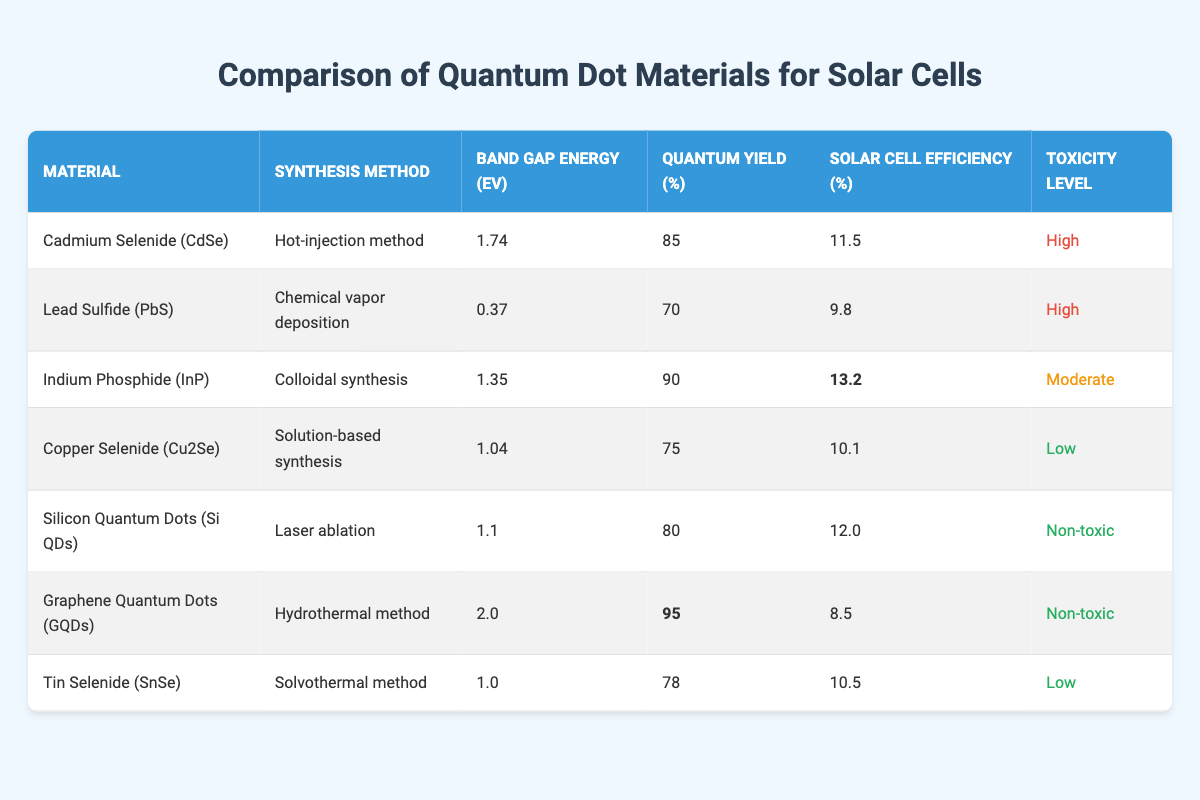What material has the highest solar cell efficiency? The solar cell efficiency of each material is listed in the table. By scanning through the values, Indium Phosphide (InP) has the highest solar cell efficiency at 13.2%.
Answer: Indium Phosphide (InP) Which material has the lowest band gap energy? The band gap energy for each material is provided. Among them, Lead Sulfide (PbS) has the lowest band gap energy of 0.37 eV.
Answer: Lead Sulfide (PbS) What is the quantum yield of Graphene Quantum Dots? The quantum yield for Graphene Quantum Dots (GQDs) is directly displayed in the table, which states it is 95%.
Answer: 95% How many materials have a toxicity level classified as "High"? The table indicates that there are two materials with a "High" toxicity level: Cadmium Selenide (CdSe) and Lead Sulfide (PbS).
Answer: 2 What is the average solar cell efficiency of materials with "Low" toxicity? The materials with "Low" toxicity are Copper Selenide (Cu2Se) at 10.1% and Tin Selenide (SnSe) at 10.5%. The average is calculated as (10.1 + 10.5) / 2 = 10.3%.
Answer: 10.3% Is the quantum yield of Silicon Quantum Dots higher than that of Copper Selenide? The quantum yield for Silicon Quantum Dots is 80%, while for Copper Selenide it is 75%. Since 80% is greater than 75%, the statement is true.
Answer: Yes What is the difference in solar cell efficiency between Indium Phosphide and Lead Sulfide? Indium Phosphide has a solar cell efficiency of 13.2% and Lead Sulfide has 9.8%. The difference is 13.2 - 9.8 = 3.4%.
Answer: 3.4% Which materials have a band gap energy greater than 1.5 eV? By examining the table, Cadmium Selenide (CdSe) at 1.74 eV and Graphene Quantum Dots (GQDs) at 2.0 eV have band gap energies greater than 1.5 eV.
Answer: Cadmium Selenide (CdSe) and Graphene Quantum Dots (GQDs) How many materials in the table are synthesized using a method classified as 'solution-based' or 'vapor deposition'? The methods listed are Hot-injection, Chemical vapor deposition, Colloidal synthesis, Solution-based synthesis, Laser ablation, Hydrothermal, and Solvothermal. Only Lead Sulfide (PbS) and Copper Selenide (Cu2Se) fall under the specified categories, giving a total of 2.
Answer: 2 Which material demonstrates the highest quantum yield and what does this imply for solar cell performance? Graphene Quantum Dots (GQDs) show the highest quantum yield at 95%, which typically implies better light absorption and conversion efficiency in solar cell applications.
Answer: Graphene Quantum Dots (GQDs); implies better light absorption 